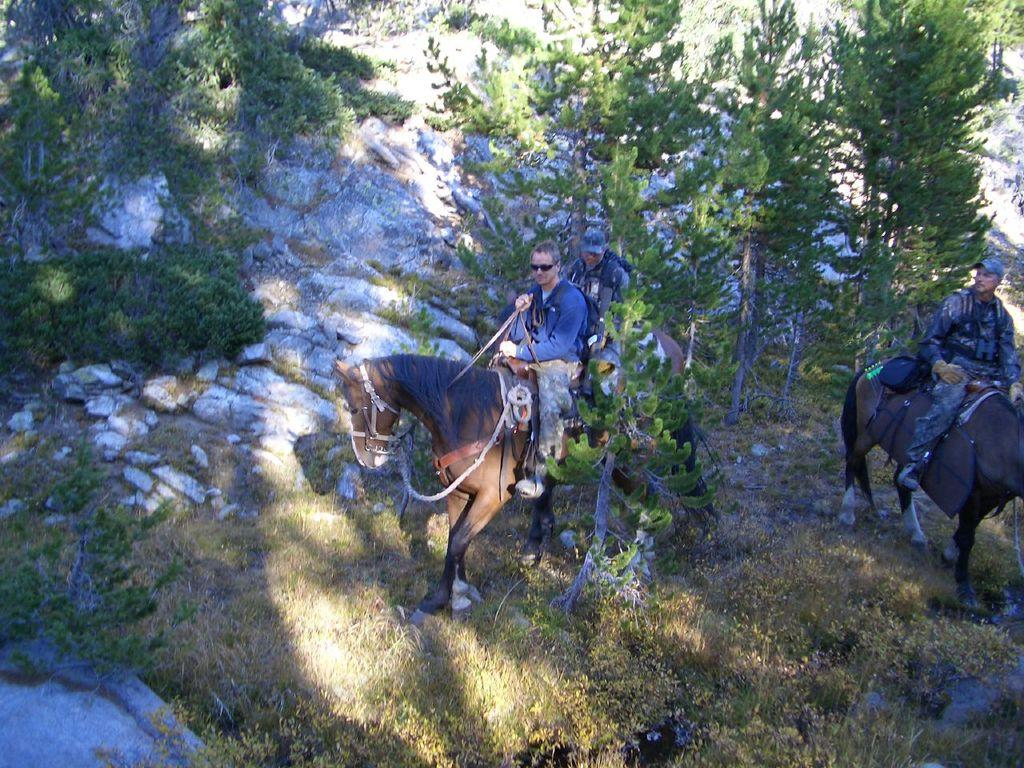What type of landscape is depicted in the image? The image features hills. What type of vegetation can be seen in the image? There is grass and trees in the image. How many people are present in the image? Two people are present in the image. What are the two people doing in the image? The two people are sitting on black color horses. What type of doll can be seen interacting with a jellyfish in the image? There is no doll or jellyfish present in the image; it features hills, grass, trees, and two people sitting on horses. 